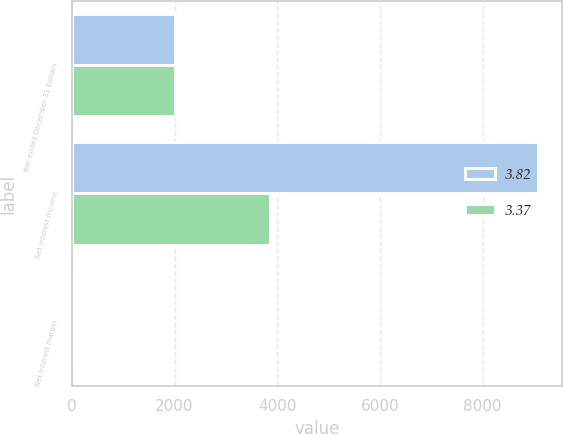Convert chart. <chart><loc_0><loc_0><loc_500><loc_500><stacked_bar_chart><ecel><fcel>Year ended December 31 Dollars<fcel>Net interest income<fcel>Net interest margin<nl><fcel>3.82<fcel>2009<fcel>9083<fcel>3.82<nl><fcel>3.37<fcel>2008<fcel>3854<fcel>3.37<nl></chart> 